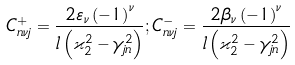Convert formula to latex. <formula><loc_0><loc_0><loc_500><loc_500>C _ { n \nu j } ^ { + } = \frac { 2 \varepsilon _ { \nu } \left ( - 1 \right ) ^ { \nu } } { l \left ( \varkappa _ { 2 } ^ { 2 } - \gamma _ { j n } ^ { 2 } \right ) } ; C _ { n \nu j } ^ { - } = \frac { 2 \beta _ { \nu } \left ( - 1 \right ) ^ { \nu } } { l \left ( \varkappa _ { 2 } ^ { 2 } - \gamma _ { j n } ^ { 2 } \right ) }</formula> 